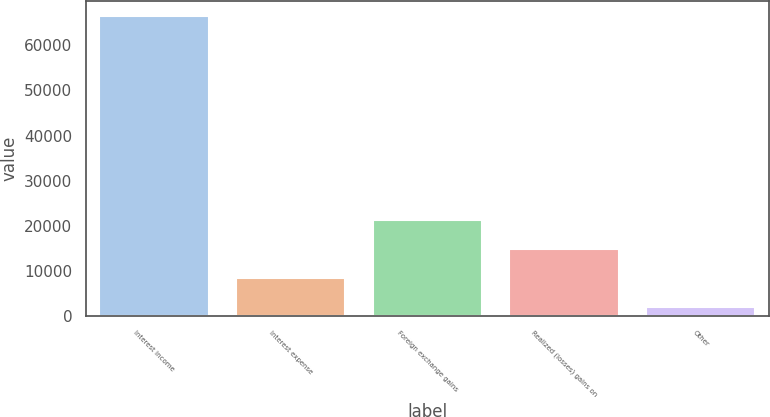Convert chart to OTSL. <chart><loc_0><loc_0><loc_500><loc_500><bar_chart><fcel>Interest income<fcel>Interest expense<fcel>Foreign exchange gains<fcel>Realized (losses) gains on<fcel>Other<nl><fcel>66417<fcel>8405.7<fcel>21297.1<fcel>14851.4<fcel>1960<nl></chart> 